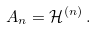<formula> <loc_0><loc_0><loc_500><loc_500>\, A _ { n } = \mathcal { H } ^ { ( n ) } \, .</formula> 